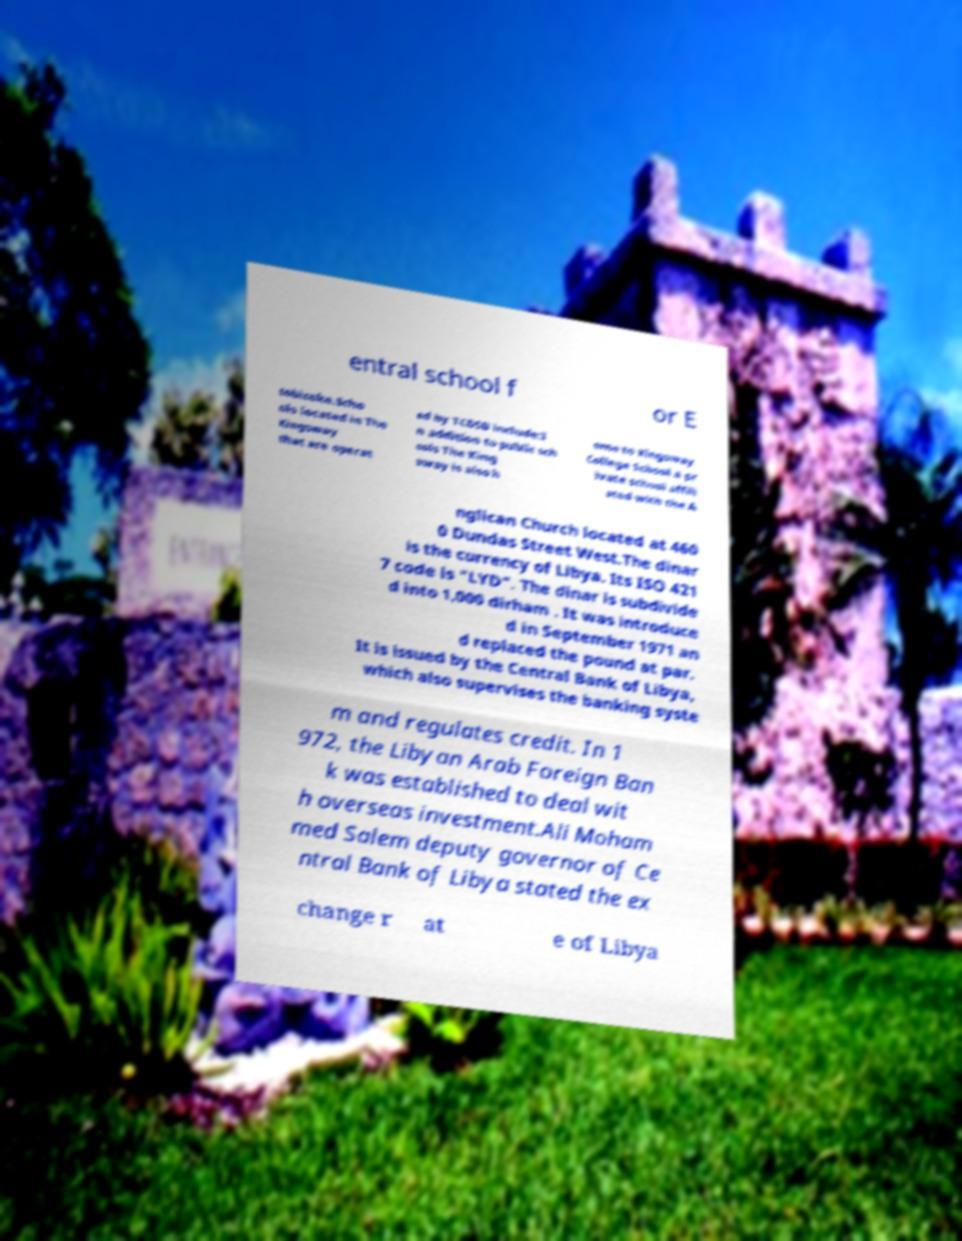Can you read and provide the text displayed in the image?This photo seems to have some interesting text. Can you extract and type it out for me? entral school f or E tobicoke.Scho ols located in The Kingsway that are operat ed by TCDSB include:I n addition to public sch ools The King sway is also h ome to Kingsway College School a pr ivate school affili ated with the A nglican Church located at 460 0 Dundas Street West.The dinar is the currency of Libya. Its ISO 421 7 code is "LYD". The dinar is subdivide d into 1,000 dirham . It was introduce d in September 1971 an d replaced the pound at par. It is issued by the Central Bank of Libya, which also supervises the banking syste m and regulates credit. In 1 972, the Libyan Arab Foreign Ban k was established to deal wit h overseas investment.Ali Moham med Salem deputy governor of Ce ntral Bank of Libya stated the ex change r at e of Libya 